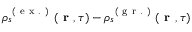<formula> <loc_0><loc_0><loc_500><loc_500>\rho _ { s } ^ { ( e x . ) } ( r , \tau ) - \rho _ { s } ^ { ( g r . ) } ( r , \tau )</formula> 